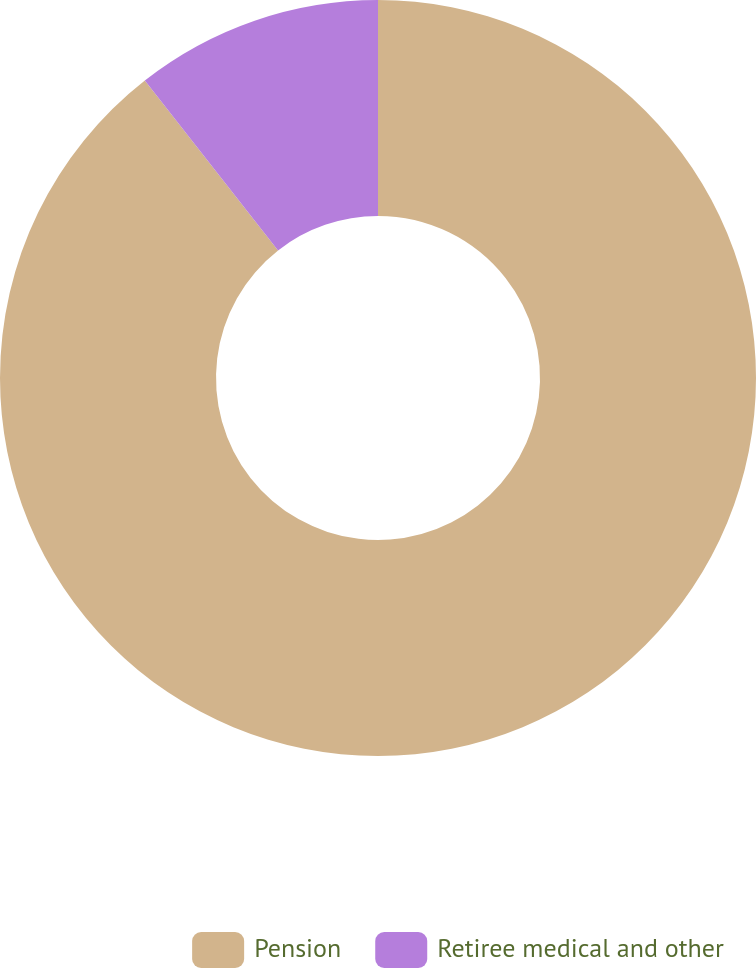Convert chart. <chart><loc_0><loc_0><loc_500><loc_500><pie_chart><fcel>Pension<fcel>Retiree medical and other<nl><fcel>89.42%<fcel>10.58%<nl></chart> 